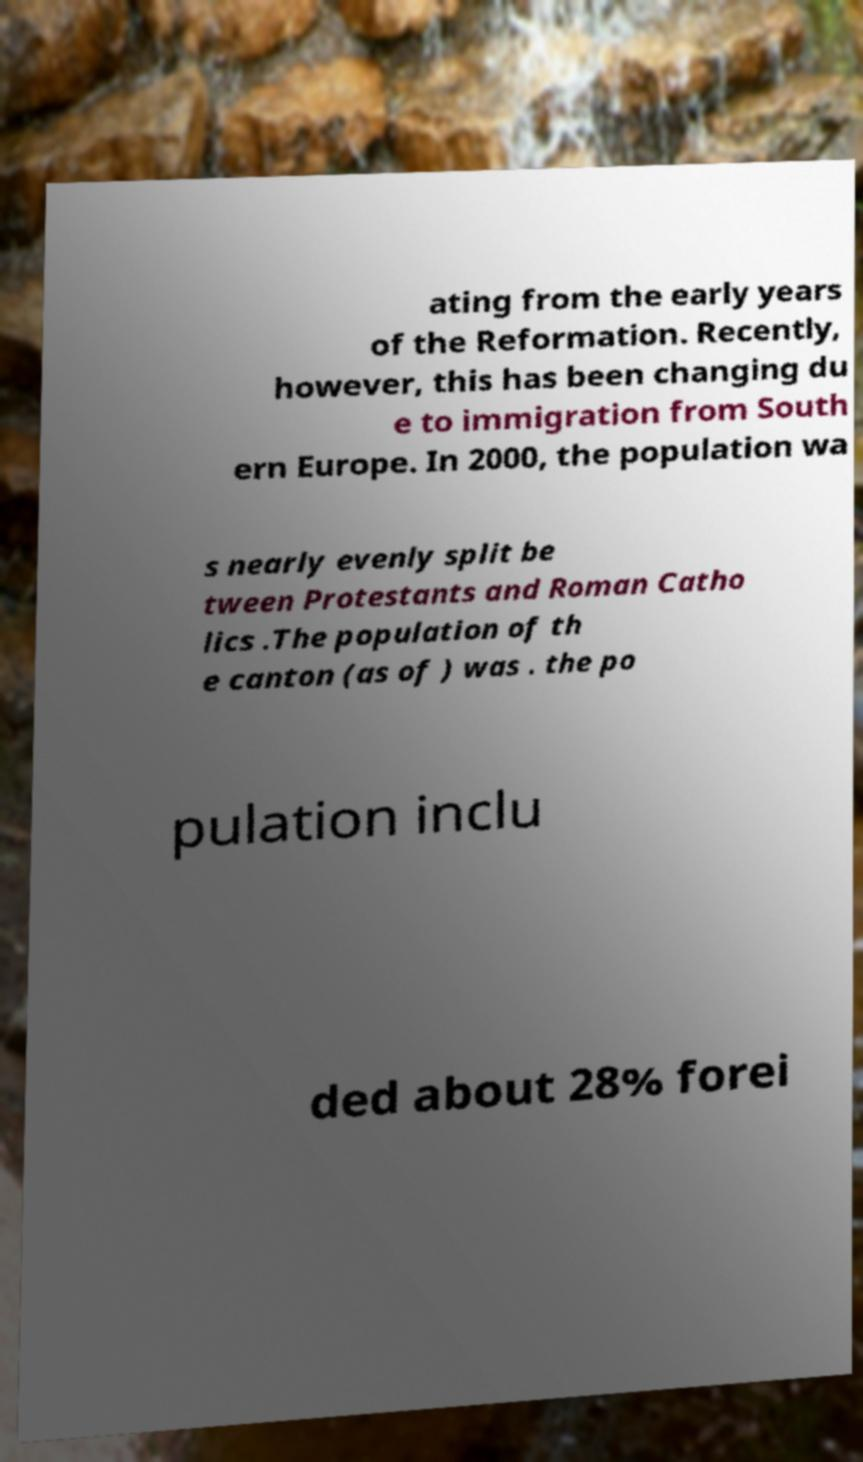There's text embedded in this image that I need extracted. Can you transcribe it verbatim? ating from the early years of the Reformation. Recently, however, this has been changing du e to immigration from South ern Europe. In 2000, the population wa s nearly evenly split be tween Protestants and Roman Catho lics .The population of th e canton (as of ) was . the po pulation inclu ded about 28% forei 